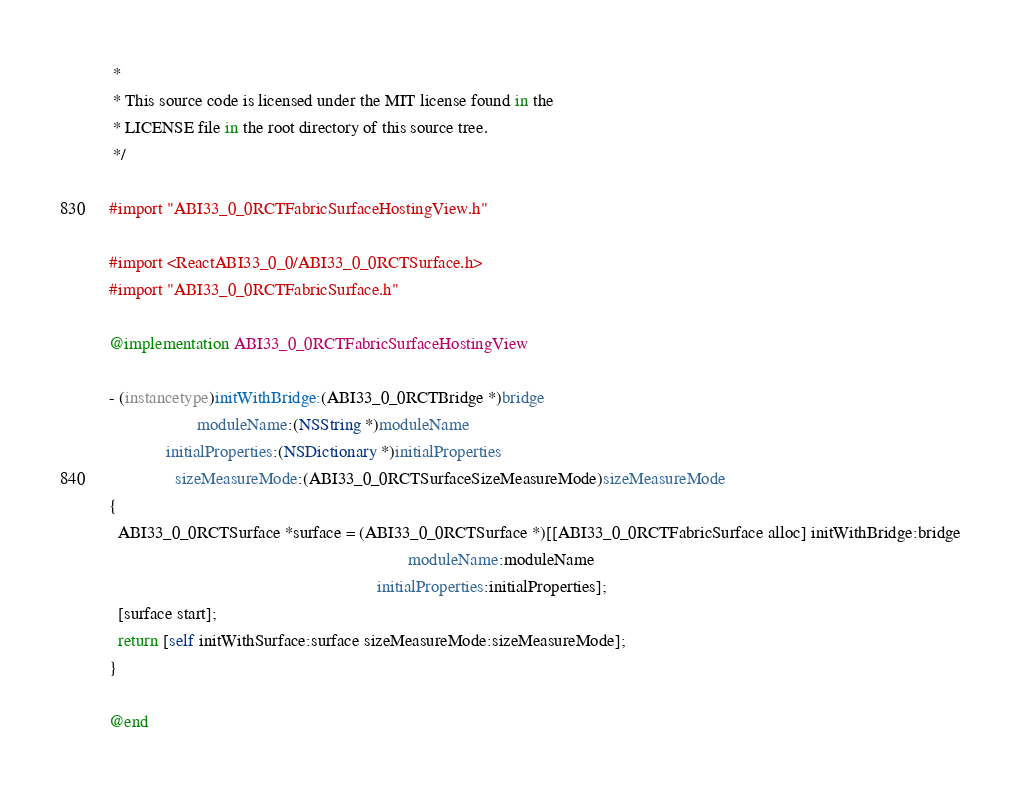Convert code to text. <code><loc_0><loc_0><loc_500><loc_500><_ObjectiveC_> *
 * This source code is licensed under the MIT license found in the
 * LICENSE file in the root directory of this source tree.
 */

#import "ABI33_0_0RCTFabricSurfaceHostingView.h"

#import <ReactABI33_0_0/ABI33_0_0RCTSurface.h>
#import "ABI33_0_0RCTFabricSurface.h"

@implementation ABI33_0_0RCTFabricSurfaceHostingView

- (instancetype)initWithBridge:(ABI33_0_0RCTBridge *)bridge
                    moduleName:(NSString *)moduleName
             initialProperties:(NSDictionary *)initialProperties
               sizeMeasureMode:(ABI33_0_0RCTSurfaceSizeMeasureMode)sizeMeasureMode
{
  ABI33_0_0RCTSurface *surface = (ABI33_0_0RCTSurface *)[[ABI33_0_0RCTFabricSurface alloc] initWithBridge:bridge
                                                                    moduleName:moduleName
                                                             initialProperties:initialProperties];
  [surface start];
  return [self initWithSurface:surface sizeMeasureMode:sizeMeasureMode];
}

@end
</code> 